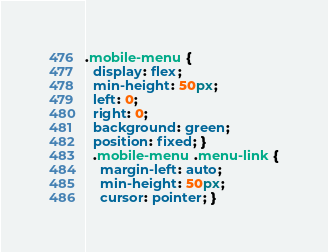Convert code to text. <code><loc_0><loc_0><loc_500><loc_500><_CSS_>.mobile-menu {
  display: flex;
  min-height: 50px;
  left: 0;
  right: 0;
  background: green;
  position: fixed; }
  .mobile-menu .menu-link {
    margin-left: auto;
    min-height: 50px;
    cursor: pointer; }</code> 